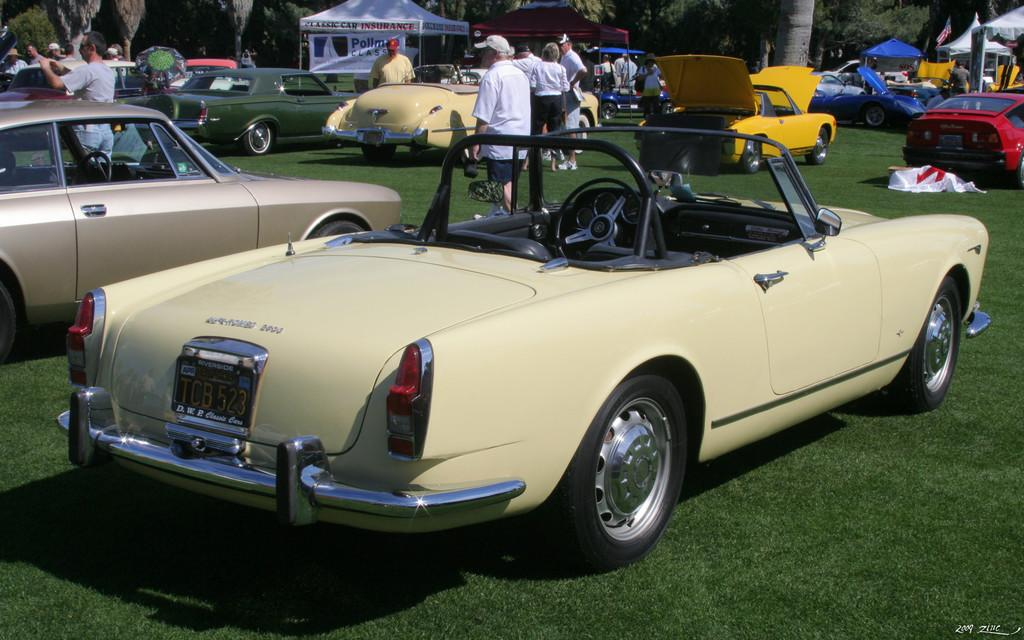What types of objects can be seen in the image? There are vehicles in the image. Can you describe the appearance of the vehicles? The vehicles are in different colors. Where are the vehicles located? The vehicles are on the ground. What can be found on the ground where the vehicles are located? There is grass on the ground. Who or what else is present in the image? There are persons in the image. What structures can be seen in the image? Tents are arranged in the image. What is visible in the background of the image? There are trees in the background of the image. What type of glass is being used to build the mountain in the image? There is no mountain or glass present in the image. What kind of cap is the person wearing in the image? There is no person wearing a cap in the image. 